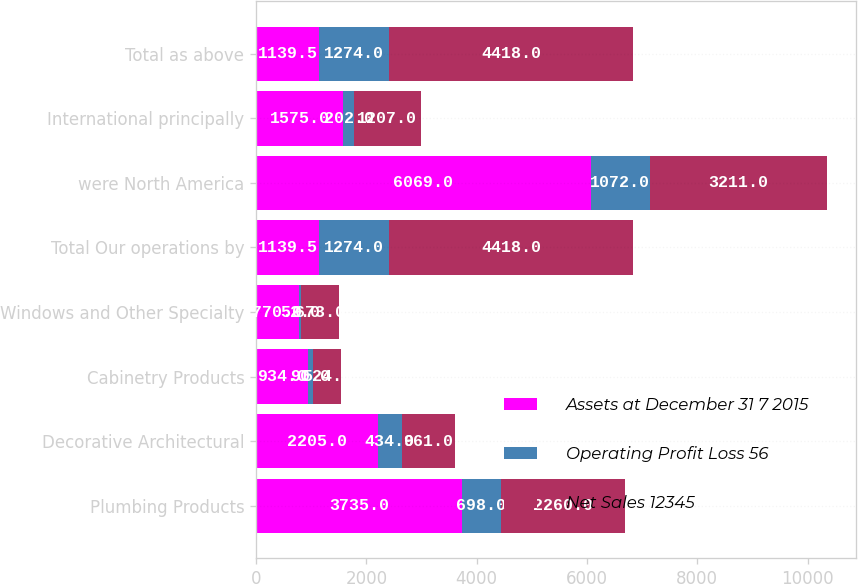Convert chart to OTSL. <chart><loc_0><loc_0><loc_500><loc_500><stacked_bar_chart><ecel><fcel>Plumbing Products<fcel>Decorative Architectural<fcel>Cabinetry Products<fcel>Windows and Other Specialty<fcel>Total Our operations by<fcel>were North America<fcel>International principally<fcel>Total as above<nl><fcel>Assets at December 31 7 2015<fcel>3735<fcel>2205<fcel>934<fcel>770<fcel>1139.5<fcel>6069<fcel>1575<fcel>1139.5<nl><fcel>Operating Profit Loss 56<fcel>698<fcel>434<fcel>90<fcel>52<fcel>1274<fcel>1072<fcel>202<fcel>1274<nl><fcel>Net Sales 12345<fcel>2260<fcel>961<fcel>524<fcel>673<fcel>4418<fcel>3211<fcel>1207<fcel>4418<nl></chart> 